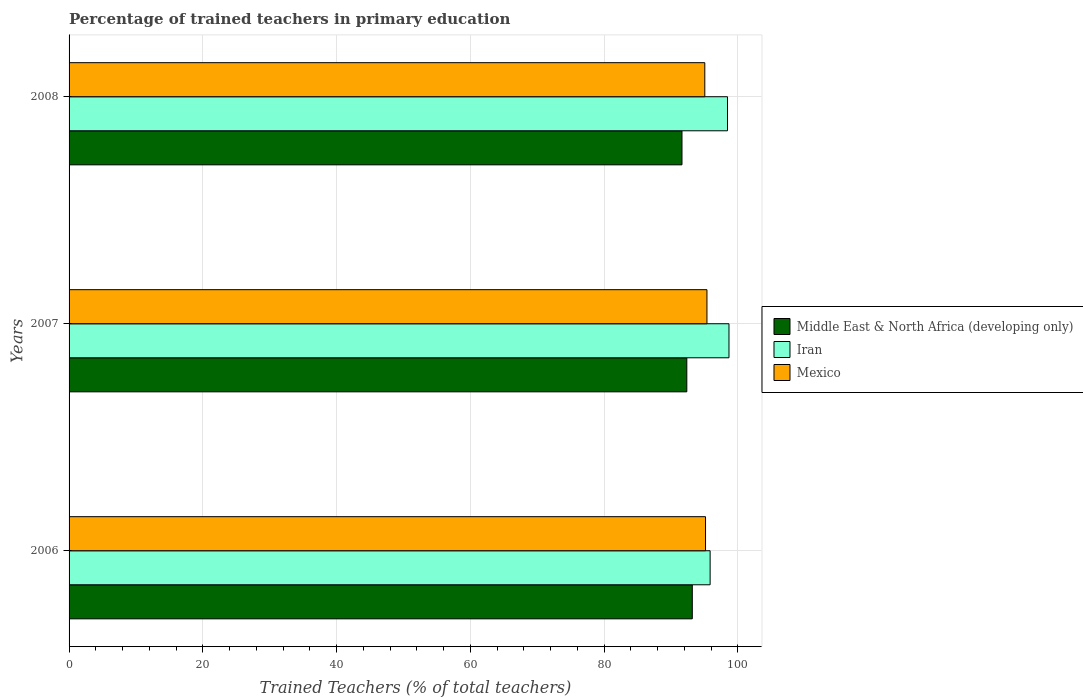How many groups of bars are there?
Keep it short and to the point. 3. How many bars are there on the 3rd tick from the top?
Ensure brevity in your answer.  3. What is the label of the 2nd group of bars from the top?
Your answer should be compact. 2007. In how many cases, is the number of bars for a given year not equal to the number of legend labels?
Make the answer very short. 0. What is the percentage of trained teachers in Iran in 2008?
Your response must be concise. 98.44. Across all years, what is the maximum percentage of trained teachers in Mexico?
Provide a succinct answer. 95.37. Across all years, what is the minimum percentage of trained teachers in Middle East & North Africa (developing only)?
Offer a very short reply. 91.64. In which year was the percentage of trained teachers in Iran maximum?
Keep it short and to the point. 2007. What is the total percentage of trained teachers in Iran in the graph?
Ensure brevity in your answer.  292.94. What is the difference between the percentage of trained teachers in Middle East & North Africa (developing only) in 2006 and that in 2008?
Make the answer very short. 1.54. What is the difference between the percentage of trained teachers in Middle East & North Africa (developing only) in 2006 and the percentage of trained teachers in Mexico in 2008?
Ensure brevity in your answer.  -1.87. What is the average percentage of trained teachers in Iran per year?
Your answer should be compact. 97.65. In the year 2006, what is the difference between the percentage of trained teachers in Mexico and percentage of trained teachers in Middle East & North Africa (developing only)?
Offer a terse response. 1.98. In how many years, is the percentage of trained teachers in Iran greater than 36 %?
Offer a terse response. 3. What is the ratio of the percentage of trained teachers in Middle East & North Africa (developing only) in 2006 to that in 2008?
Your response must be concise. 1.02. Is the percentage of trained teachers in Iran in 2006 less than that in 2008?
Offer a very short reply. Yes. Is the difference between the percentage of trained teachers in Mexico in 2006 and 2008 greater than the difference between the percentage of trained teachers in Middle East & North Africa (developing only) in 2006 and 2008?
Your answer should be very brief. No. What is the difference between the highest and the second highest percentage of trained teachers in Middle East & North Africa (developing only)?
Make the answer very short. 0.82. What is the difference between the highest and the lowest percentage of trained teachers in Mexico?
Your answer should be compact. 0.32. In how many years, is the percentage of trained teachers in Mexico greater than the average percentage of trained teachers in Mexico taken over all years?
Keep it short and to the point. 1. What does the 1st bar from the top in 2006 represents?
Offer a terse response. Mexico. What does the 2nd bar from the bottom in 2007 represents?
Your answer should be compact. Iran. Is it the case that in every year, the sum of the percentage of trained teachers in Middle East & North Africa (developing only) and percentage of trained teachers in Iran is greater than the percentage of trained teachers in Mexico?
Keep it short and to the point. Yes. What is the difference between two consecutive major ticks on the X-axis?
Your answer should be compact. 20. Are the values on the major ticks of X-axis written in scientific E-notation?
Provide a succinct answer. No. Does the graph contain any zero values?
Provide a short and direct response. No. Where does the legend appear in the graph?
Provide a succinct answer. Center right. How many legend labels are there?
Provide a succinct answer. 3. How are the legend labels stacked?
Offer a very short reply. Vertical. What is the title of the graph?
Offer a very short reply. Percentage of trained teachers in primary education. What is the label or title of the X-axis?
Give a very brief answer. Trained Teachers (% of total teachers). What is the label or title of the Y-axis?
Offer a very short reply. Years. What is the Trained Teachers (% of total teachers) of Middle East & North Africa (developing only) in 2006?
Provide a succinct answer. 93.18. What is the Trained Teachers (% of total teachers) of Iran in 2006?
Your answer should be very brief. 95.84. What is the Trained Teachers (% of total teachers) in Mexico in 2006?
Make the answer very short. 95.15. What is the Trained Teachers (% of total teachers) in Middle East & North Africa (developing only) in 2007?
Ensure brevity in your answer.  92.36. What is the Trained Teachers (% of total teachers) of Iran in 2007?
Provide a succinct answer. 98.66. What is the Trained Teachers (% of total teachers) in Mexico in 2007?
Provide a short and direct response. 95.37. What is the Trained Teachers (% of total teachers) in Middle East & North Africa (developing only) in 2008?
Give a very brief answer. 91.64. What is the Trained Teachers (% of total teachers) of Iran in 2008?
Provide a short and direct response. 98.44. What is the Trained Teachers (% of total teachers) of Mexico in 2008?
Your answer should be compact. 95.05. Across all years, what is the maximum Trained Teachers (% of total teachers) in Middle East & North Africa (developing only)?
Your response must be concise. 93.18. Across all years, what is the maximum Trained Teachers (% of total teachers) of Iran?
Offer a very short reply. 98.66. Across all years, what is the maximum Trained Teachers (% of total teachers) of Mexico?
Keep it short and to the point. 95.37. Across all years, what is the minimum Trained Teachers (% of total teachers) of Middle East & North Africa (developing only)?
Give a very brief answer. 91.64. Across all years, what is the minimum Trained Teachers (% of total teachers) of Iran?
Make the answer very short. 95.84. Across all years, what is the minimum Trained Teachers (% of total teachers) of Mexico?
Your answer should be compact. 95.05. What is the total Trained Teachers (% of total teachers) in Middle East & North Africa (developing only) in the graph?
Keep it short and to the point. 277.17. What is the total Trained Teachers (% of total teachers) in Iran in the graph?
Make the answer very short. 292.94. What is the total Trained Teachers (% of total teachers) of Mexico in the graph?
Offer a terse response. 285.57. What is the difference between the Trained Teachers (% of total teachers) in Middle East & North Africa (developing only) in 2006 and that in 2007?
Provide a short and direct response. 0.82. What is the difference between the Trained Teachers (% of total teachers) in Iran in 2006 and that in 2007?
Your answer should be very brief. -2.82. What is the difference between the Trained Teachers (% of total teachers) in Mexico in 2006 and that in 2007?
Provide a succinct answer. -0.22. What is the difference between the Trained Teachers (% of total teachers) in Middle East & North Africa (developing only) in 2006 and that in 2008?
Provide a succinct answer. 1.54. What is the difference between the Trained Teachers (% of total teachers) of Iran in 2006 and that in 2008?
Offer a very short reply. -2.6. What is the difference between the Trained Teachers (% of total teachers) of Mexico in 2006 and that in 2008?
Keep it short and to the point. 0.11. What is the difference between the Trained Teachers (% of total teachers) in Middle East & North Africa (developing only) in 2007 and that in 2008?
Your response must be concise. 0.72. What is the difference between the Trained Teachers (% of total teachers) in Iran in 2007 and that in 2008?
Ensure brevity in your answer.  0.22. What is the difference between the Trained Teachers (% of total teachers) in Mexico in 2007 and that in 2008?
Your answer should be very brief. 0.32. What is the difference between the Trained Teachers (% of total teachers) of Middle East & North Africa (developing only) in 2006 and the Trained Teachers (% of total teachers) of Iran in 2007?
Your answer should be compact. -5.48. What is the difference between the Trained Teachers (% of total teachers) in Middle East & North Africa (developing only) in 2006 and the Trained Teachers (% of total teachers) in Mexico in 2007?
Provide a succinct answer. -2.19. What is the difference between the Trained Teachers (% of total teachers) of Iran in 2006 and the Trained Teachers (% of total teachers) of Mexico in 2007?
Your response must be concise. 0.47. What is the difference between the Trained Teachers (% of total teachers) in Middle East & North Africa (developing only) in 2006 and the Trained Teachers (% of total teachers) in Iran in 2008?
Your answer should be very brief. -5.26. What is the difference between the Trained Teachers (% of total teachers) of Middle East & North Africa (developing only) in 2006 and the Trained Teachers (% of total teachers) of Mexico in 2008?
Your response must be concise. -1.87. What is the difference between the Trained Teachers (% of total teachers) in Iran in 2006 and the Trained Teachers (% of total teachers) in Mexico in 2008?
Ensure brevity in your answer.  0.8. What is the difference between the Trained Teachers (% of total teachers) of Middle East & North Africa (developing only) in 2007 and the Trained Teachers (% of total teachers) of Iran in 2008?
Your answer should be very brief. -6.08. What is the difference between the Trained Teachers (% of total teachers) of Middle East & North Africa (developing only) in 2007 and the Trained Teachers (% of total teachers) of Mexico in 2008?
Give a very brief answer. -2.69. What is the difference between the Trained Teachers (% of total teachers) in Iran in 2007 and the Trained Teachers (% of total teachers) in Mexico in 2008?
Give a very brief answer. 3.62. What is the average Trained Teachers (% of total teachers) of Middle East & North Africa (developing only) per year?
Make the answer very short. 92.39. What is the average Trained Teachers (% of total teachers) in Iran per year?
Your answer should be compact. 97.65. What is the average Trained Teachers (% of total teachers) in Mexico per year?
Provide a succinct answer. 95.19. In the year 2006, what is the difference between the Trained Teachers (% of total teachers) in Middle East & North Africa (developing only) and Trained Teachers (% of total teachers) in Iran?
Provide a succinct answer. -2.66. In the year 2006, what is the difference between the Trained Teachers (% of total teachers) in Middle East & North Africa (developing only) and Trained Teachers (% of total teachers) in Mexico?
Offer a terse response. -1.98. In the year 2006, what is the difference between the Trained Teachers (% of total teachers) of Iran and Trained Teachers (% of total teachers) of Mexico?
Make the answer very short. 0.69. In the year 2007, what is the difference between the Trained Teachers (% of total teachers) of Middle East & North Africa (developing only) and Trained Teachers (% of total teachers) of Iran?
Provide a short and direct response. -6.31. In the year 2007, what is the difference between the Trained Teachers (% of total teachers) in Middle East & North Africa (developing only) and Trained Teachers (% of total teachers) in Mexico?
Make the answer very short. -3.01. In the year 2007, what is the difference between the Trained Teachers (% of total teachers) of Iran and Trained Teachers (% of total teachers) of Mexico?
Offer a very short reply. 3.29. In the year 2008, what is the difference between the Trained Teachers (% of total teachers) in Middle East & North Africa (developing only) and Trained Teachers (% of total teachers) in Iran?
Give a very brief answer. -6.8. In the year 2008, what is the difference between the Trained Teachers (% of total teachers) in Middle East & North Africa (developing only) and Trained Teachers (% of total teachers) in Mexico?
Your answer should be compact. -3.41. In the year 2008, what is the difference between the Trained Teachers (% of total teachers) in Iran and Trained Teachers (% of total teachers) in Mexico?
Your response must be concise. 3.39. What is the ratio of the Trained Teachers (% of total teachers) of Middle East & North Africa (developing only) in 2006 to that in 2007?
Your response must be concise. 1.01. What is the ratio of the Trained Teachers (% of total teachers) in Iran in 2006 to that in 2007?
Offer a very short reply. 0.97. What is the ratio of the Trained Teachers (% of total teachers) of Middle East & North Africa (developing only) in 2006 to that in 2008?
Offer a terse response. 1.02. What is the ratio of the Trained Teachers (% of total teachers) in Iran in 2006 to that in 2008?
Provide a succinct answer. 0.97. What is the ratio of the Trained Teachers (% of total teachers) of Middle East & North Africa (developing only) in 2007 to that in 2008?
Provide a short and direct response. 1.01. What is the ratio of the Trained Teachers (% of total teachers) of Iran in 2007 to that in 2008?
Provide a short and direct response. 1. What is the ratio of the Trained Teachers (% of total teachers) in Mexico in 2007 to that in 2008?
Ensure brevity in your answer.  1. What is the difference between the highest and the second highest Trained Teachers (% of total teachers) in Middle East & North Africa (developing only)?
Offer a very short reply. 0.82. What is the difference between the highest and the second highest Trained Teachers (% of total teachers) in Iran?
Offer a terse response. 0.22. What is the difference between the highest and the second highest Trained Teachers (% of total teachers) in Mexico?
Provide a short and direct response. 0.22. What is the difference between the highest and the lowest Trained Teachers (% of total teachers) of Middle East & North Africa (developing only)?
Give a very brief answer. 1.54. What is the difference between the highest and the lowest Trained Teachers (% of total teachers) of Iran?
Your answer should be compact. 2.82. What is the difference between the highest and the lowest Trained Teachers (% of total teachers) in Mexico?
Keep it short and to the point. 0.32. 